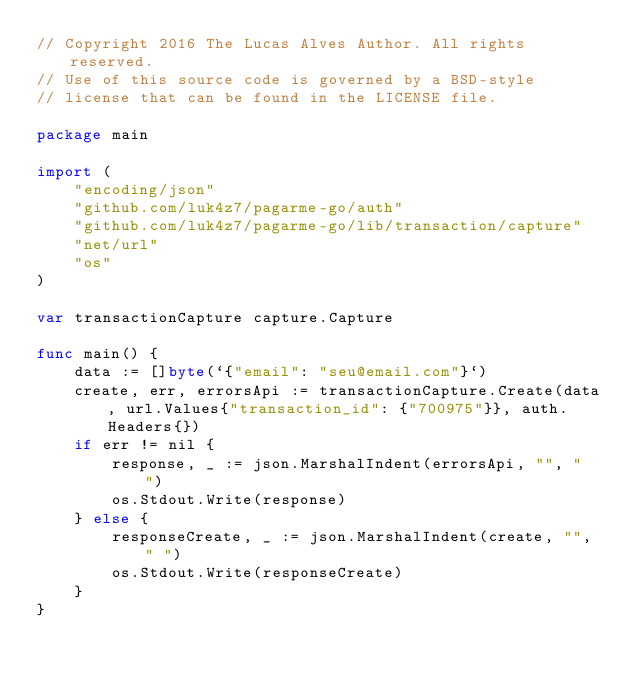<code> <loc_0><loc_0><loc_500><loc_500><_Go_>// Copyright 2016 The Lucas Alves Author. All rights reserved.
// Use of this source code is governed by a BSD-style
// license that can be found in the LICENSE file.

package main

import (
	"encoding/json"
	"github.com/luk4z7/pagarme-go/auth"
	"github.com/luk4z7/pagarme-go/lib/transaction/capture"
	"net/url"
	"os"
)

var transactionCapture capture.Capture

func main() {
	data := []byte(`{"email": "seu@email.com"}`)
	create, err, errorsApi := transactionCapture.Create(data, url.Values{"transaction_id": {"700975"}}, auth.Headers{})
	if err != nil {
		response, _ := json.MarshalIndent(errorsApi, "", "  ")
		os.Stdout.Write(response)
	} else {
		responseCreate, _ := json.MarshalIndent(create, "", " ")
		os.Stdout.Write(responseCreate)
	}
}
</code> 